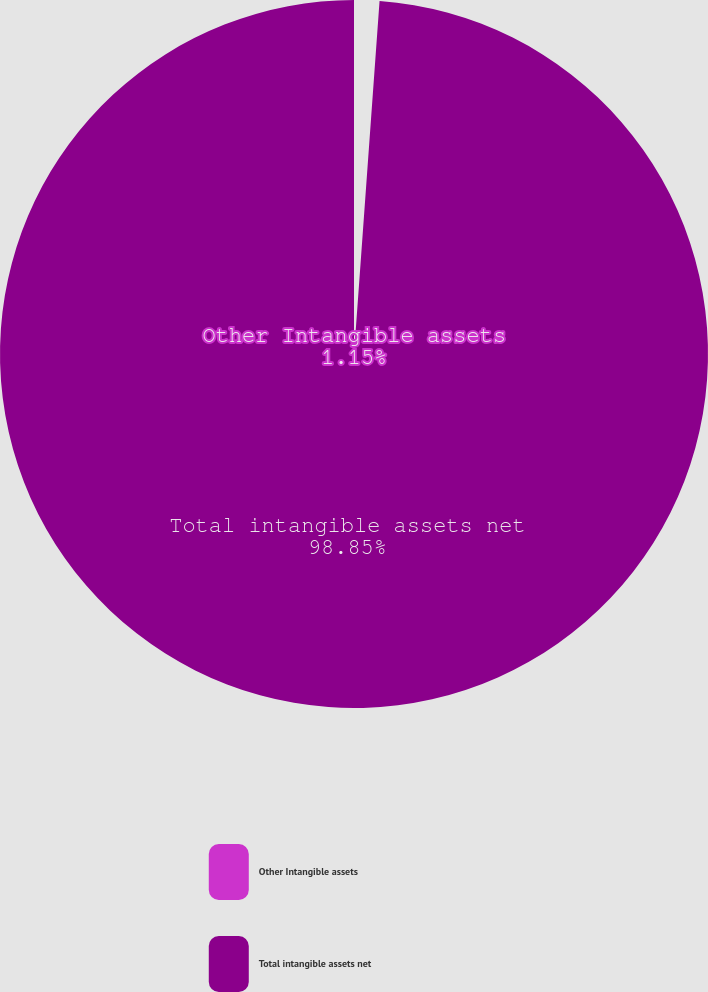Convert chart. <chart><loc_0><loc_0><loc_500><loc_500><pie_chart><fcel>Other Intangible assets<fcel>Total intangible assets net<nl><fcel>1.15%<fcel>98.85%<nl></chart> 